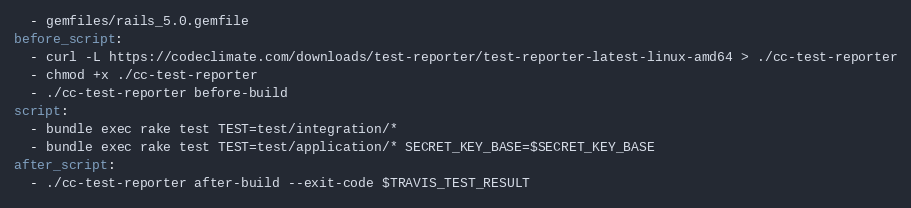<code> <loc_0><loc_0><loc_500><loc_500><_YAML_>  - gemfiles/rails_5.0.gemfile
before_script:
  - curl -L https://codeclimate.com/downloads/test-reporter/test-reporter-latest-linux-amd64 > ./cc-test-reporter
  - chmod +x ./cc-test-reporter
  - ./cc-test-reporter before-build
script:
  - bundle exec rake test TEST=test/integration/*
  - bundle exec rake test TEST=test/application/* SECRET_KEY_BASE=$SECRET_KEY_BASE
after_script:
  - ./cc-test-reporter after-build --exit-code $TRAVIS_TEST_RESULT

</code> 